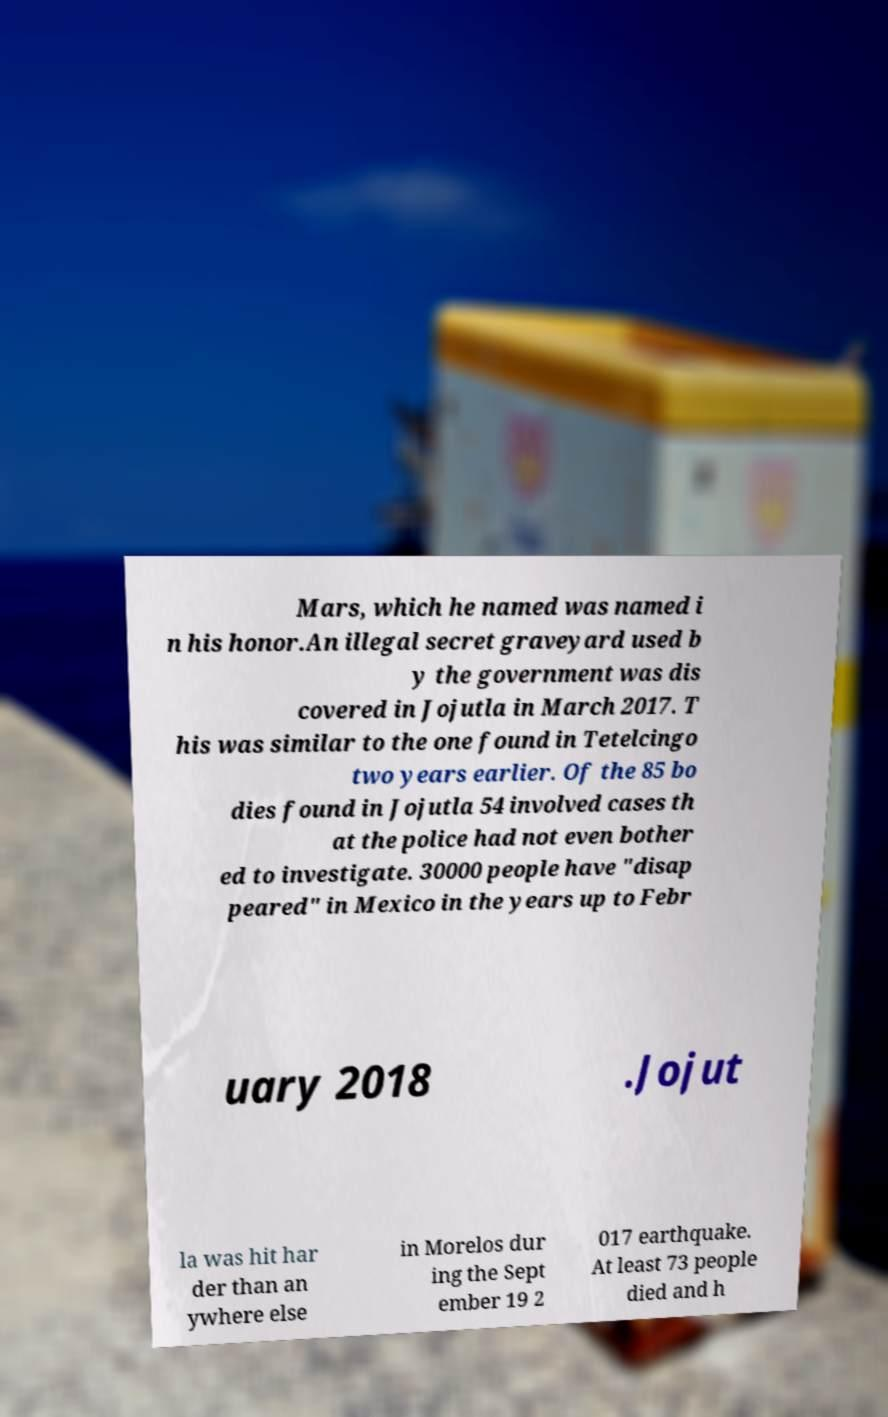Can you read and provide the text displayed in the image?This photo seems to have some interesting text. Can you extract and type it out for me? Mars, which he named was named i n his honor.An illegal secret graveyard used b y the government was dis covered in Jojutla in March 2017. T his was similar to the one found in Tetelcingo two years earlier. Of the 85 bo dies found in Jojutla 54 involved cases th at the police had not even bother ed to investigate. 30000 people have "disap peared" in Mexico in the years up to Febr uary 2018 .Jojut la was hit har der than an ywhere else in Morelos dur ing the Sept ember 19 2 017 earthquake. At least 73 people died and h 